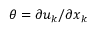Convert formula to latex. <formula><loc_0><loc_0><loc_500><loc_500>\theta = \partial u _ { k } / \partial x _ { k }</formula> 